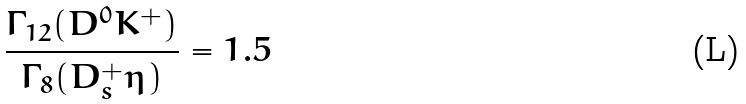<formula> <loc_0><loc_0><loc_500><loc_500>\frac { \Gamma _ { 1 2 } ( D ^ { 0 } K ^ { + } ) } { \Gamma _ { 8 } ( D _ { s } ^ { + } \eta ) } = 1 . 5</formula> 